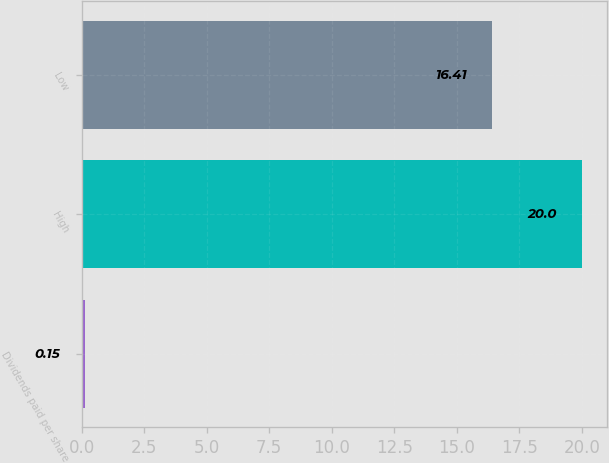<chart> <loc_0><loc_0><loc_500><loc_500><bar_chart><fcel>Dividends paid per share<fcel>High<fcel>Low<nl><fcel>0.15<fcel>20<fcel>16.41<nl></chart> 